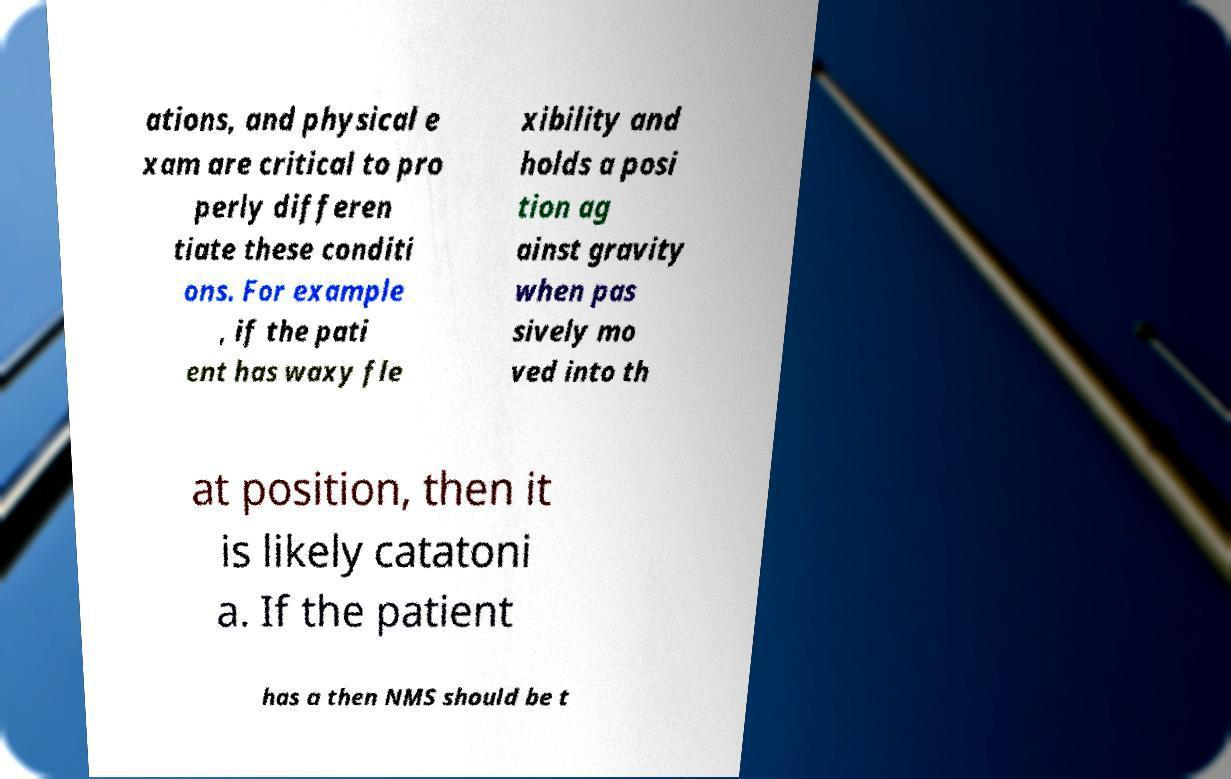Can you read and provide the text displayed in the image?This photo seems to have some interesting text. Can you extract and type it out for me? ations, and physical e xam are critical to pro perly differen tiate these conditi ons. For example , if the pati ent has waxy fle xibility and holds a posi tion ag ainst gravity when pas sively mo ved into th at position, then it is likely catatoni a. If the patient has a then NMS should be t 